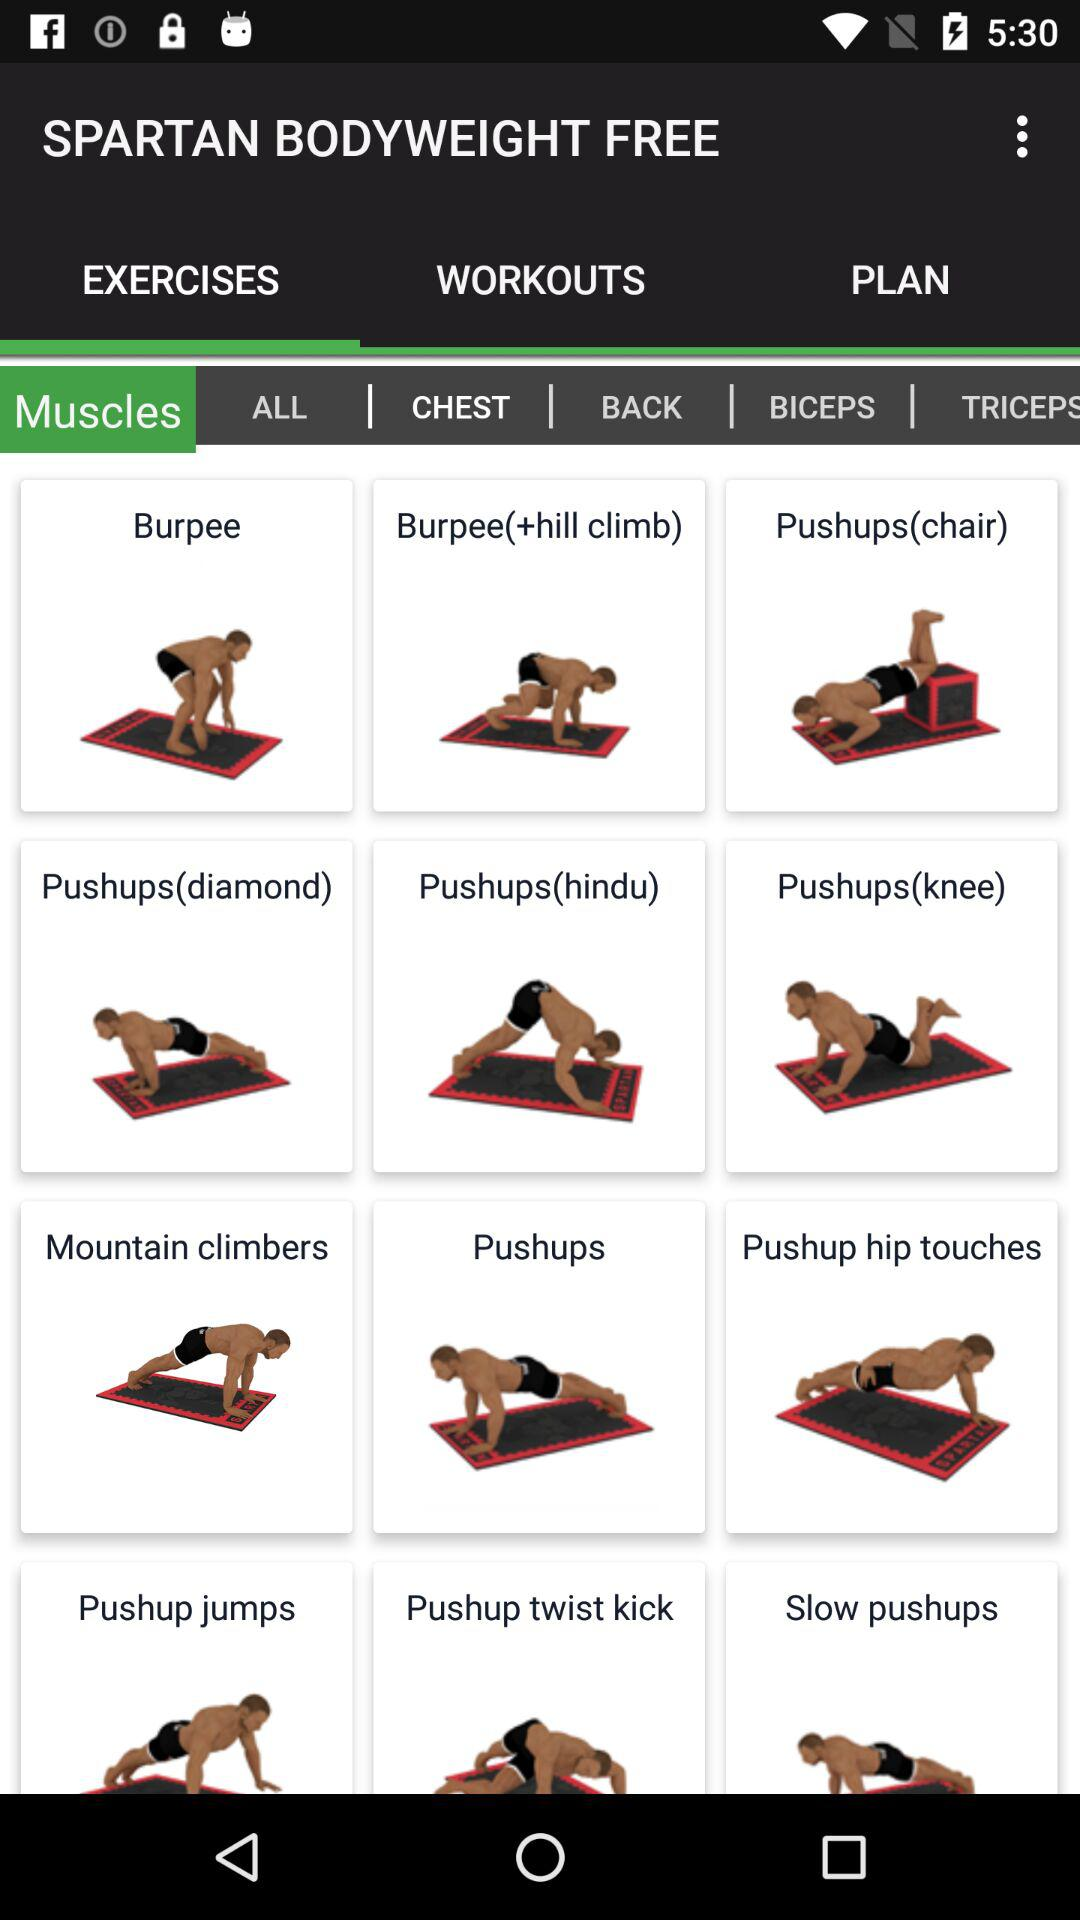What is the selected tab? The selected tabs are "EXERCISES" and "CHEST". 